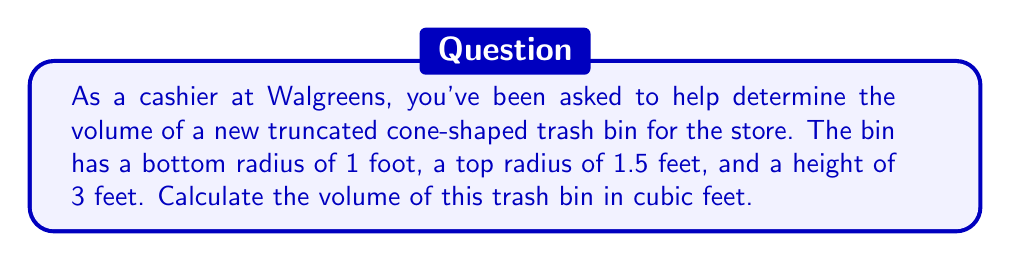Provide a solution to this math problem. Let's approach this step-by-step:

1) The formula for the volume of a truncated cone is:

   $$V = \frac{1}{3}\pi h(R^2 + r^2 + Rr)$$

   Where:
   $V$ = volume
   $h$ = height
   $R$ = radius of the larger base (top)
   $r$ = radius of the smaller base (bottom)

2) We're given:
   $h = 3$ feet
   $R = 1.5$ feet
   $r = 1$ foot

3) Let's substitute these values into our formula:

   $$V = \frac{1}{3}\pi \cdot 3(1.5^2 + 1^2 + 1.5 \cdot 1)$$

4) Simplify inside the parentheses:
   $$V = \pi(2.25 + 1 + 1.5)$$

5) Add inside the parentheses:
   $$V = \pi(4.75)$$

6) Multiply:
   $$V = 4.75\pi$$

7) If we want to give a decimal approximation (using $\pi \approx 3.14159$):
   $$V \approx 4.75 \cdot 3.14159 \approx 14.92\ \text{cubic feet}$$

[asy]
import geometry;

size(200);

pair A = (0,0), B = (3,0), C = (4.5,3), D = (1.5,3);
draw(A--B--C--D--cycle);
draw(A--D);

label("1'", (A+B)/2, S);
label("1.5'", (C+D)/2, N);
label("3'", (B+C)/2, E);

[/asy]
Answer: $\frac{19\pi}{4}$ cubic feet or approximately 14.92 cubic feet 